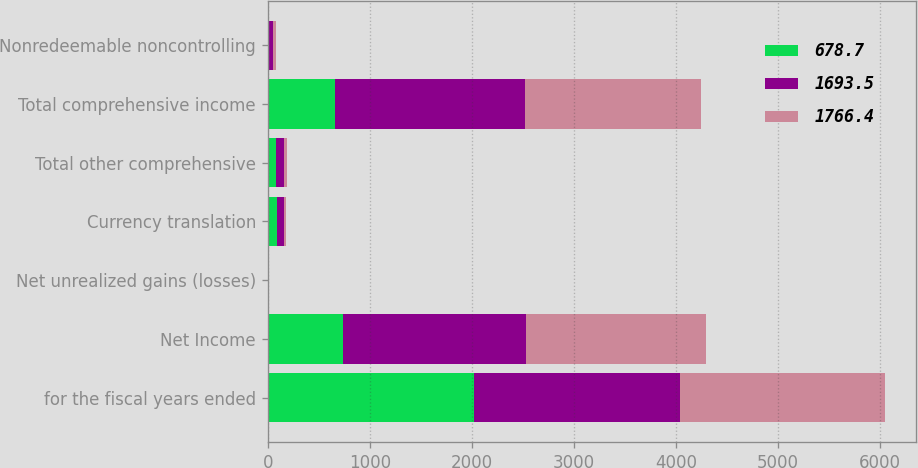Convert chart to OTSL. <chart><loc_0><loc_0><loc_500><loc_500><stacked_bar_chart><ecel><fcel>for the fiscal years ended<fcel>Net Income<fcel>Net unrealized gains (losses)<fcel>Currency translation<fcel>Total other comprehensive<fcel>Total comprehensive income<fcel>Nonredeemable noncontrolling<nl><fcel>678.7<fcel>2018<fcel>742.7<fcel>1.9<fcel>91.9<fcel>85.7<fcel>657<fcel>8.9<nl><fcel>1693.5<fcel>2017<fcel>1789.7<fcel>2.1<fcel>65.4<fcel>69.7<fcel>1859.4<fcel>40<nl><fcel>1766.4<fcel>2016<fcel>1757.7<fcel>2.4<fcel>18.3<fcel>33.2<fcel>1724.5<fcel>29.4<nl></chart> 